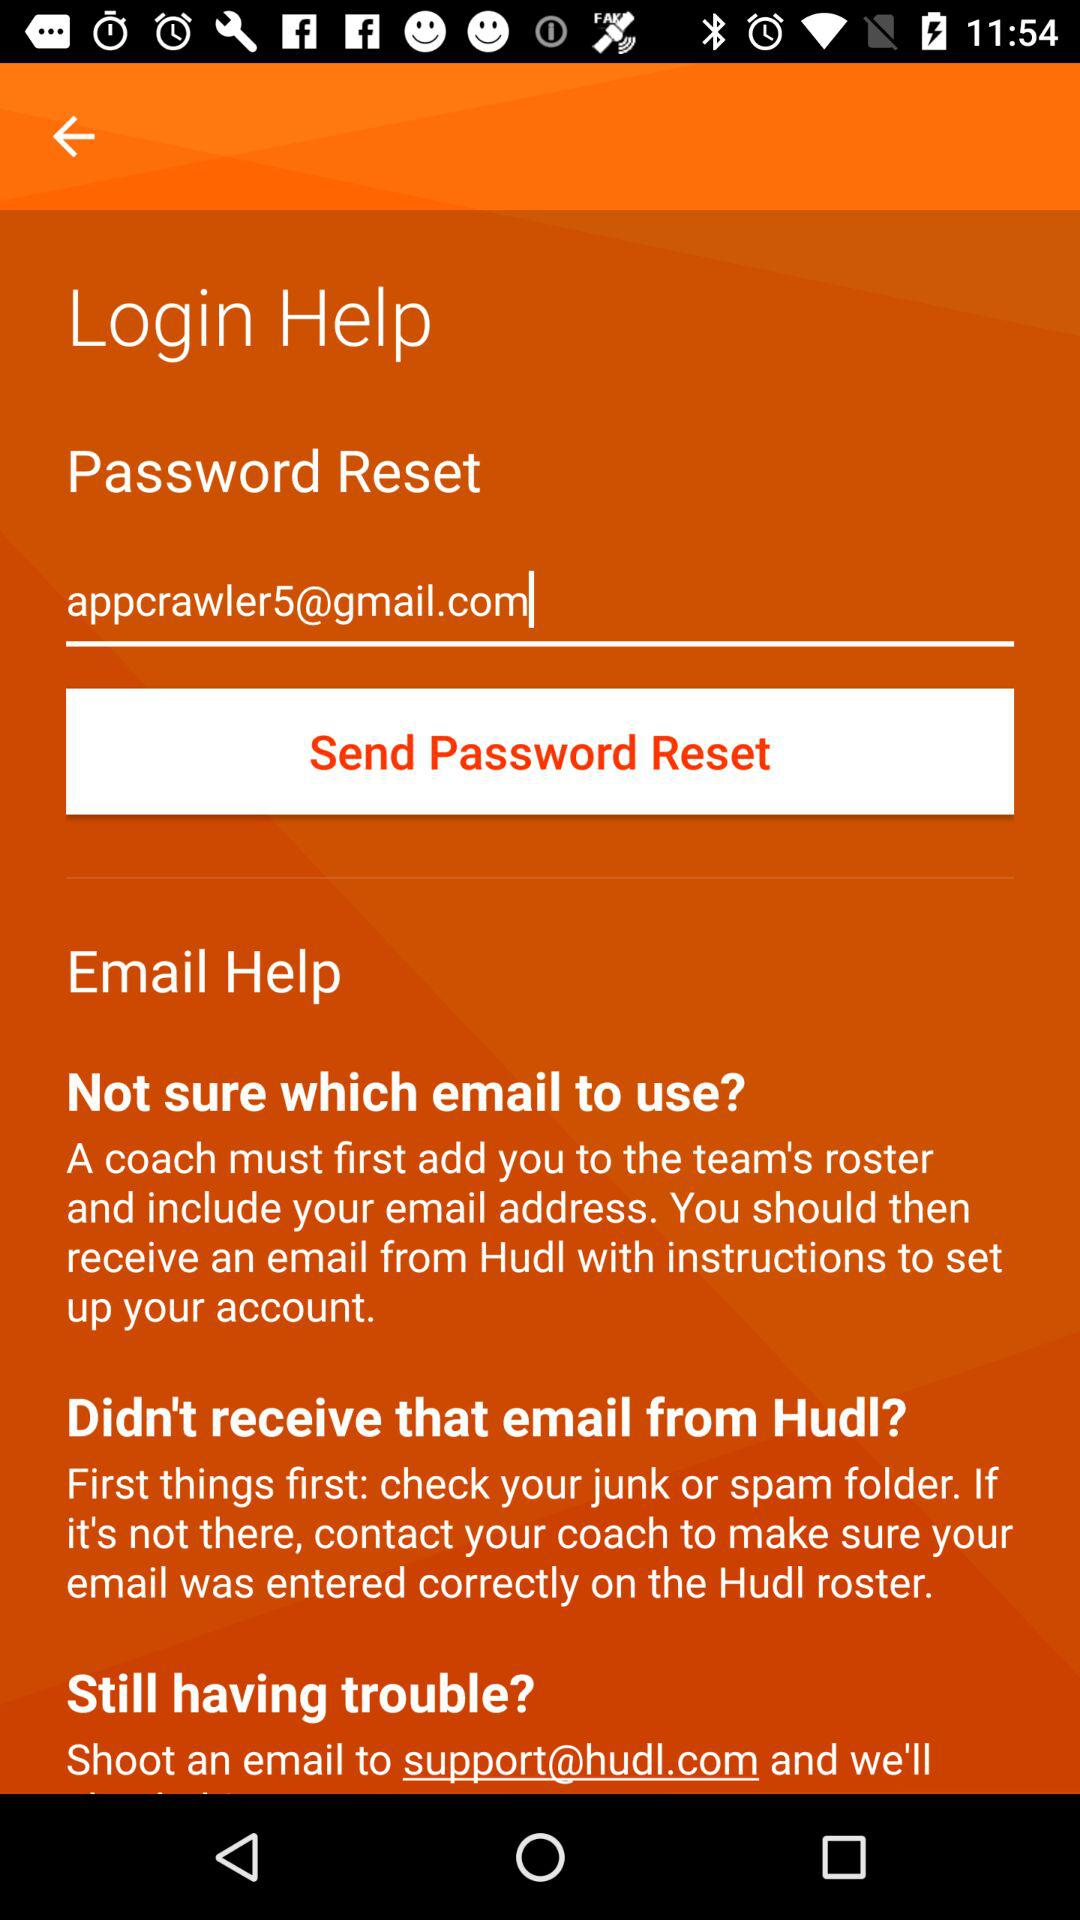What is the email address? The email address is appcrawler5@gmail.com. 